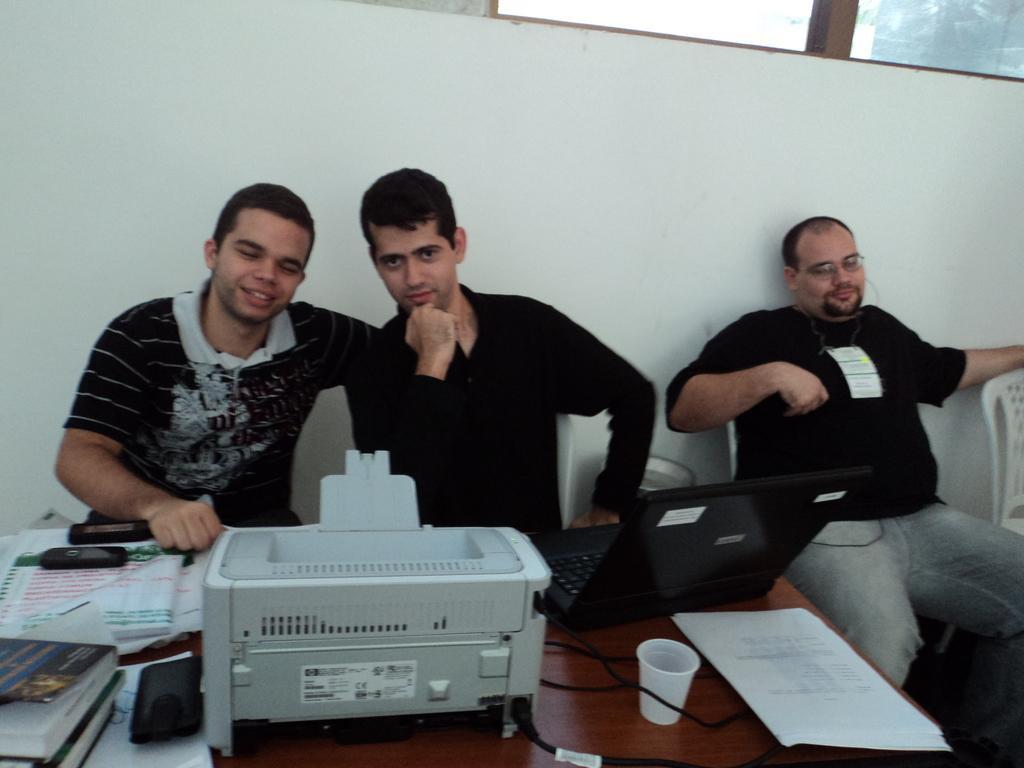Please provide a concise description of this image. There are three people in the picture who are sitting on the chairs wearing black color tee shirts in front of a table and we have printer, laptop,papers, cup and phone and some diaries on the table. 